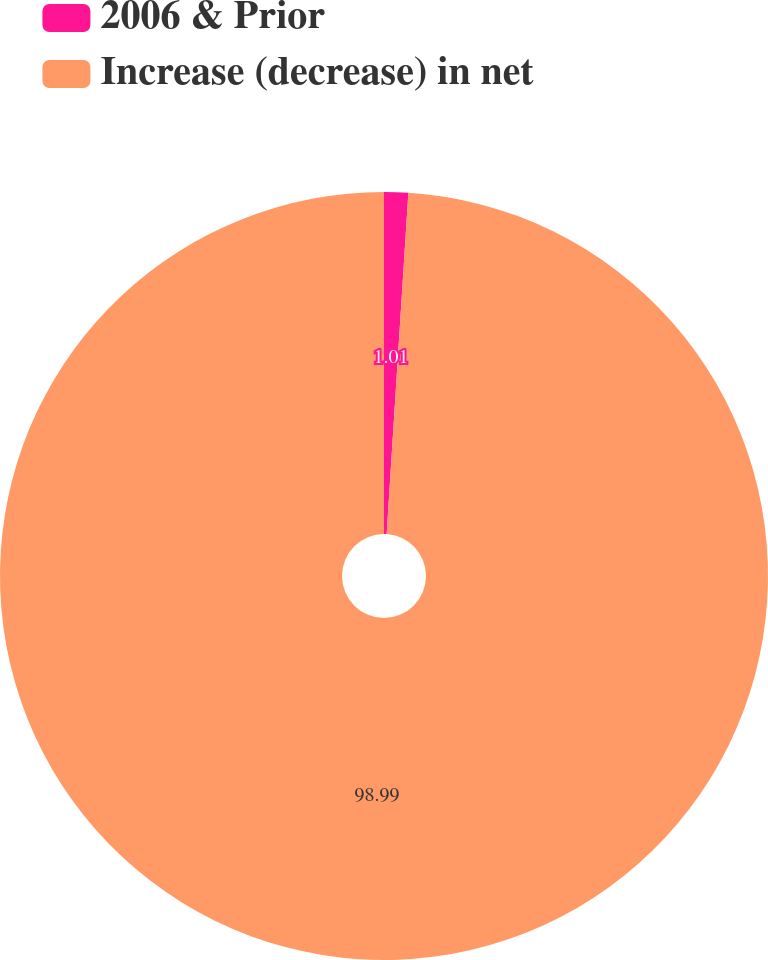Convert chart to OTSL. <chart><loc_0><loc_0><loc_500><loc_500><pie_chart><fcel>2006 & Prior<fcel>Increase (decrease) in net<nl><fcel>1.01%<fcel>98.99%<nl></chart> 